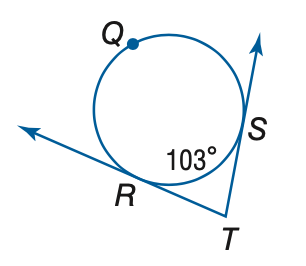Answer the mathemtical geometry problem and directly provide the correct option letter.
Question: Find the measure of \angle T.
Choices: A: 60 B: 77 C: 103 D: 154 B 